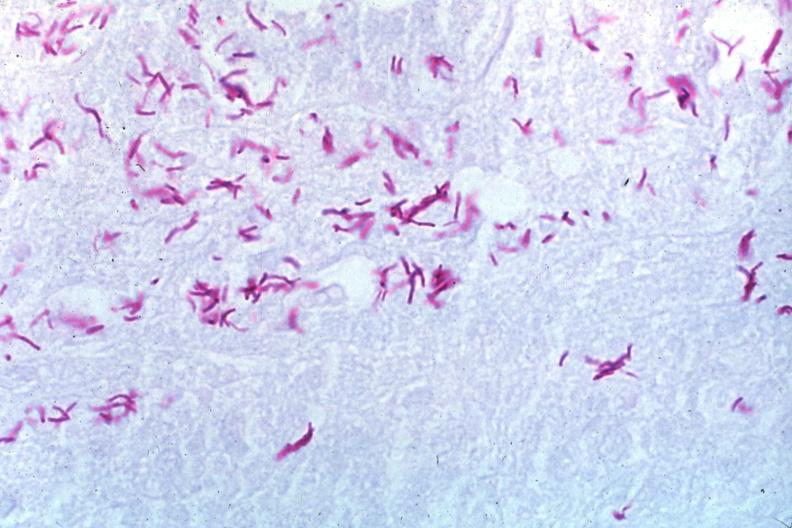does oil acid stain a zillion organisms?
Answer the question using a single word or phrase. Yes 